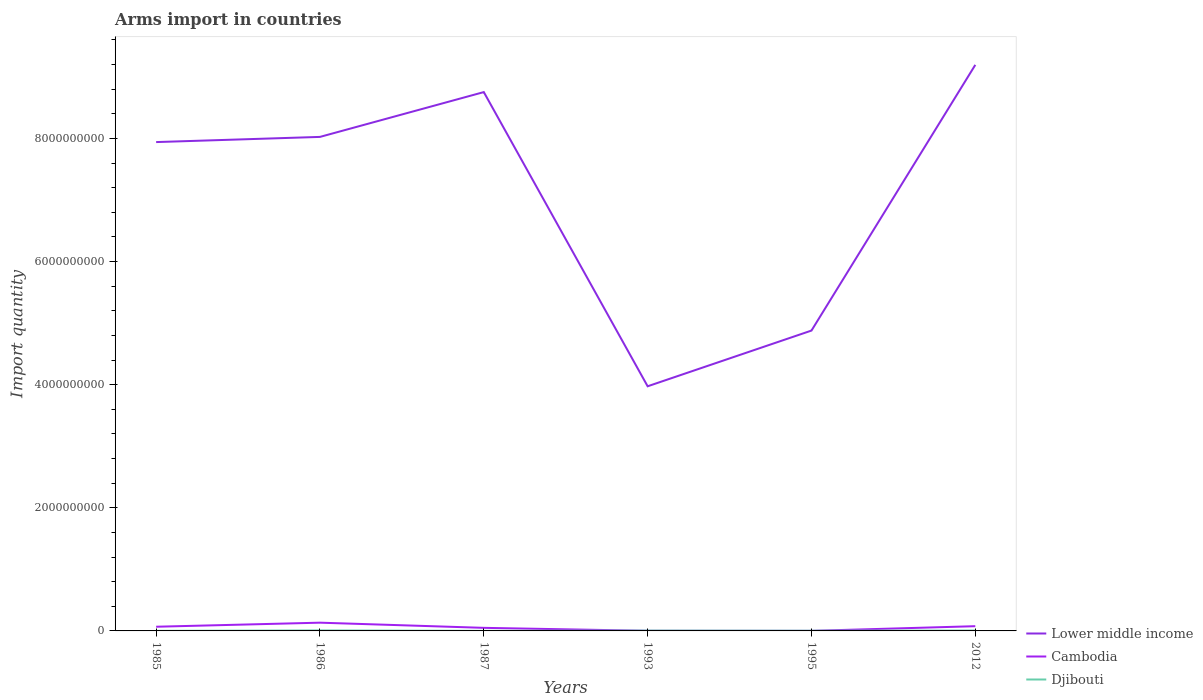How many different coloured lines are there?
Make the answer very short. 3. Is the number of lines equal to the number of legend labels?
Offer a very short reply. Yes. Across all years, what is the maximum total arms import in Djibouti?
Provide a short and direct response. 1.00e+06. In which year was the total arms import in Lower middle income maximum?
Ensure brevity in your answer.  1993. What is the difference between the highest and the second highest total arms import in Lower middle income?
Make the answer very short. 5.22e+09. Is the total arms import in Lower middle income strictly greater than the total arms import in Cambodia over the years?
Your answer should be compact. No. How many lines are there?
Provide a short and direct response. 3. What is the difference between two consecutive major ticks on the Y-axis?
Ensure brevity in your answer.  2.00e+09. Are the values on the major ticks of Y-axis written in scientific E-notation?
Your answer should be very brief. No. Does the graph contain any zero values?
Your answer should be compact. No. How many legend labels are there?
Give a very brief answer. 3. What is the title of the graph?
Make the answer very short. Arms import in countries. What is the label or title of the X-axis?
Make the answer very short. Years. What is the label or title of the Y-axis?
Make the answer very short. Import quantity. What is the Import quantity in Lower middle income in 1985?
Offer a very short reply. 7.94e+09. What is the Import quantity of Cambodia in 1985?
Offer a very short reply. 6.80e+07. What is the Import quantity of Lower middle income in 1986?
Your response must be concise. 8.02e+09. What is the Import quantity of Cambodia in 1986?
Your response must be concise. 1.34e+08. What is the Import quantity in Djibouti in 1986?
Provide a short and direct response. 8.00e+06. What is the Import quantity of Lower middle income in 1987?
Offer a very short reply. 8.75e+09. What is the Import quantity of Cambodia in 1987?
Your answer should be compact. 5.00e+07. What is the Import quantity of Lower middle income in 1993?
Provide a short and direct response. 3.97e+09. What is the Import quantity in Lower middle income in 1995?
Ensure brevity in your answer.  4.88e+09. What is the Import quantity in Cambodia in 1995?
Provide a short and direct response. 1.00e+06. What is the Import quantity of Djibouti in 1995?
Offer a very short reply. 3.00e+06. What is the Import quantity of Lower middle income in 2012?
Keep it short and to the point. 9.20e+09. What is the Import quantity of Cambodia in 2012?
Keep it short and to the point. 7.70e+07. Across all years, what is the maximum Import quantity in Lower middle income?
Make the answer very short. 9.20e+09. Across all years, what is the maximum Import quantity of Cambodia?
Your answer should be compact. 1.34e+08. Across all years, what is the maximum Import quantity of Djibouti?
Make the answer very short. 8.00e+06. Across all years, what is the minimum Import quantity of Lower middle income?
Offer a terse response. 3.97e+09. Across all years, what is the minimum Import quantity in Cambodia?
Provide a succinct answer. 1.00e+06. Across all years, what is the minimum Import quantity in Djibouti?
Offer a terse response. 1.00e+06. What is the total Import quantity in Lower middle income in the graph?
Your answer should be very brief. 4.28e+1. What is the total Import quantity in Cambodia in the graph?
Provide a short and direct response. 3.32e+08. What is the total Import quantity in Djibouti in the graph?
Ensure brevity in your answer.  2.40e+07. What is the difference between the Import quantity of Lower middle income in 1985 and that in 1986?
Make the answer very short. -8.40e+07. What is the difference between the Import quantity of Cambodia in 1985 and that in 1986?
Ensure brevity in your answer.  -6.60e+07. What is the difference between the Import quantity of Djibouti in 1985 and that in 1986?
Offer a terse response. -7.00e+06. What is the difference between the Import quantity in Lower middle income in 1985 and that in 1987?
Provide a succinct answer. -8.12e+08. What is the difference between the Import quantity in Cambodia in 1985 and that in 1987?
Provide a succinct answer. 1.80e+07. What is the difference between the Import quantity of Lower middle income in 1985 and that in 1993?
Offer a terse response. 3.97e+09. What is the difference between the Import quantity of Cambodia in 1985 and that in 1993?
Offer a very short reply. 6.60e+07. What is the difference between the Import quantity of Djibouti in 1985 and that in 1993?
Provide a short and direct response. -4.00e+06. What is the difference between the Import quantity of Lower middle income in 1985 and that in 1995?
Keep it short and to the point. 3.06e+09. What is the difference between the Import quantity in Cambodia in 1985 and that in 1995?
Your response must be concise. 6.70e+07. What is the difference between the Import quantity of Djibouti in 1985 and that in 1995?
Your response must be concise. -2.00e+06. What is the difference between the Import quantity in Lower middle income in 1985 and that in 2012?
Provide a short and direct response. -1.25e+09. What is the difference between the Import quantity in Cambodia in 1985 and that in 2012?
Provide a short and direct response. -9.00e+06. What is the difference between the Import quantity of Djibouti in 1985 and that in 2012?
Keep it short and to the point. -5.00e+06. What is the difference between the Import quantity of Lower middle income in 1986 and that in 1987?
Your answer should be compact. -7.28e+08. What is the difference between the Import quantity in Cambodia in 1986 and that in 1987?
Provide a short and direct response. 8.40e+07. What is the difference between the Import quantity in Lower middle income in 1986 and that in 1993?
Offer a very short reply. 4.05e+09. What is the difference between the Import quantity of Cambodia in 1986 and that in 1993?
Ensure brevity in your answer.  1.32e+08. What is the difference between the Import quantity of Lower middle income in 1986 and that in 1995?
Offer a very short reply. 3.15e+09. What is the difference between the Import quantity of Cambodia in 1986 and that in 1995?
Give a very brief answer. 1.33e+08. What is the difference between the Import quantity in Djibouti in 1986 and that in 1995?
Your answer should be compact. 5.00e+06. What is the difference between the Import quantity of Lower middle income in 1986 and that in 2012?
Provide a short and direct response. -1.17e+09. What is the difference between the Import quantity in Cambodia in 1986 and that in 2012?
Offer a terse response. 5.70e+07. What is the difference between the Import quantity of Lower middle income in 1987 and that in 1993?
Make the answer very short. 4.78e+09. What is the difference between the Import quantity of Cambodia in 1987 and that in 1993?
Your answer should be very brief. 4.80e+07. What is the difference between the Import quantity in Djibouti in 1987 and that in 1993?
Your response must be concise. -4.00e+06. What is the difference between the Import quantity in Lower middle income in 1987 and that in 1995?
Provide a short and direct response. 3.87e+09. What is the difference between the Import quantity of Cambodia in 1987 and that in 1995?
Your answer should be very brief. 4.90e+07. What is the difference between the Import quantity in Lower middle income in 1987 and that in 2012?
Give a very brief answer. -4.42e+08. What is the difference between the Import quantity of Cambodia in 1987 and that in 2012?
Offer a terse response. -2.70e+07. What is the difference between the Import quantity in Djibouti in 1987 and that in 2012?
Offer a terse response. -5.00e+06. What is the difference between the Import quantity of Lower middle income in 1993 and that in 1995?
Offer a terse response. -9.05e+08. What is the difference between the Import quantity of Djibouti in 1993 and that in 1995?
Offer a very short reply. 2.00e+06. What is the difference between the Import quantity in Lower middle income in 1993 and that in 2012?
Make the answer very short. -5.22e+09. What is the difference between the Import quantity of Cambodia in 1993 and that in 2012?
Ensure brevity in your answer.  -7.50e+07. What is the difference between the Import quantity in Djibouti in 1993 and that in 2012?
Give a very brief answer. -1.00e+06. What is the difference between the Import quantity of Lower middle income in 1995 and that in 2012?
Make the answer very short. -4.32e+09. What is the difference between the Import quantity of Cambodia in 1995 and that in 2012?
Provide a succinct answer. -7.60e+07. What is the difference between the Import quantity in Lower middle income in 1985 and the Import quantity in Cambodia in 1986?
Keep it short and to the point. 7.81e+09. What is the difference between the Import quantity of Lower middle income in 1985 and the Import quantity of Djibouti in 1986?
Provide a short and direct response. 7.93e+09. What is the difference between the Import quantity in Cambodia in 1985 and the Import quantity in Djibouti in 1986?
Provide a short and direct response. 6.00e+07. What is the difference between the Import quantity in Lower middle income in 1985 and the Import quantity in Cambodia in 1987?
Make the answer very short. 7.89e+09. What is the difference between the Import quantity in Lower middle income in 1985 and the Import quantity in Djibouti in 1987?
Provide a short and direct response. 7.94e+09. What is the difference between the Import quantity of Cambodia in 1985 and the Import quantity of Djibouti in 1987?
Your response must be concise. 6.70e+07. What is the difference between the Import quantity in Lower middle income in 1985 and the Import quantity in Cambodia in 1993?
Offer a very short reply. 7.94e+09. What is the difference between the Import quantity of Lower middle income in 1985 and the Import quantity of Djibouti in 1993?
Offer a terse response. 7.94e+09. What is the difference between the Import quantity of Cambodia in 1985 and the Import quantity of Djibouti in 1993?
Provide a succinct answer. 6.30e+07. What is the difference between the Import quantity in Lower middle income in 1985 and the Import quantity in Cambodia in 1995?
Offer a terse response. 7.94e+09. What is the difference between the Import quantity of Lower middle income in 1985 and the Import quantity of Djibouti in 1995?
Your answer should be compact. 7.94e+09. What is the difference between the Import quantity of Cambodia in 1985 and the Import quantity of Djibouti in 1995?
Give a very brief answer. 6.50e+07. What is the difference between the Import quantity of Lower middle income in 1985 and the Import quantity of Cambodia in 2012?
Your answer should be very brief. 7.86e+09. What is the difference between the Import quantity of Lower middle income in 1985 and the Import quantity of Djibouti in 2012?
Provide a short and direct response. 7.94e+09. What is the difference between the Import quantity in Cambodia in 1985 and the Import quantity in Djibouti in 2012?
Your answer should be compact. 6.20e+07. What is the difference between the Import quantity in Lower middle income in 1986 and the Import quantity in Cambodia in 1987?
Your answer should be compact. 7.98e+09. What is the difference between the Import quantity of Lower middle income in 1986 and the Import quantity of Djibouti in 1987?
Ensure brevity in your answer.  8.02e+09. What is the difference between the Import quantity in Cambodia in 1986 and the Import quantity in Djibouti in 1987?
Ensure brevity in your answer.  1.33e+08. What is the difference between the Import quantity of Lower middle income in 1986 and the Import quantity of Cambodia in 1993?
Offer a terse response. 8.02e+09. What is the difference between the Import quantity in Lower middle income in 1986 and the Import quantity in Djibouti in 1993?
Ensure brevity in your answer.  8.02e+09. What is the difference between the Import quantity in Cambodia in 1986 and the Import quantity in Djibouti in 1993?
Offer a very short reply. 1.29e+08. What is the difference between the Import quantity in Lower middle income in 1986 and the Import quantity in Cambodia in 1995?
Give a very brief answer. 8.02e+09. What is the difference between the Import quantity of Lower middle income in 1986 and the Import quantity of Djibouti in 1995?
Ensure brevity in your answer.  8.02e+09. What is the difference between the Import quantity in Cambodia in 1986 and the Import quantity in Djibouti in 1995?
Give a very brief answer. 1.31e+08. What is the difference between the Import quantity of Lower middle income in 1986 and the Import quantity of Cambodia in 2012?
Offer a very short reply. 7.95e+09. What is the difference between the Import quantity of Lower middle income in 1986 and the Import quantity of Djibouti in 2012?
Your answer should be very brief. 8.02e+09. What is the difference between the Import quantity of Cambodia in 1986 and the Import quantity of Djibouti in 2012?
Your answer should be very brief. 1.28e+08. What is the difference between the Import quantity in Lower middle income in 1987 and the Import quantity in Cambodia in 1993?
Give a very brief answer. 8.75e+09. What is the difference between the Import quantity in Lower middle income in 1987 and the Import quantity in Djibouti in 1993?
Offer a terse response. 8.75e+09. What is the difference between the Import quantity of Cambodia in 1987 and the Import quantity of Djibouti in 1993?
Ensure brevity in your answer.  4.50e+07. What is the difference between the Import quantity of Lower middle income in 1987 and the Import quantity of Cambodia in 1995?
Give a very brief answer. 8.75e+09. What is the difference between the Import quantity of Lower middle income in 1987 and the Import quantity of Djibouti in 1995?
Provide a succinct answer. 8.75e+09. What is the difference between the Import quantity of Cambodia in 1987 and the Import quantity of Djibouti in 1995?
Keep it short and to the point. 4.70e+07. What is the difference between the Import quantity of Lower middle income in 1987 and the Import quantity of Cambodia in 2012?
Offer a terse response. 8.68e+09. What is the difference between the Import quantity in Lower middle income in 1987 and the Import quantity in Djibouti in 2012?
Keep it short and to the point. 8.75e+09. What is the difference between the Import quantity of Cambodia in 1987 and the Import quantity of Djibouti in 2012?
Make the answer very short. 4.40e+07. What is the difference between the Import quantity of Lower middle income in 1993 and the Import quantity of Cambodia in 1995?
Offer a very short reply. 3.97e+09. What is the difference between the Import quantity of Lower middle income in 1993 and the Import quantity of Djibouti in 1995?
Offer a terse response. 3.97e+09. What is the difference between the Import quantity of Cambodia in 1993 and the Import quantity of Djibouti in 1995?
Your response must be concise. -1.00e+06. What is the difference between the Import quantity of Lower middle income in 1993 and the Import quantity of Cambodia in 2012?
Give a very brief answer. 3.90e+09. What is the difference between the Import quantity in Lower middle income in 1993 and the Import quantity in Djibouti in 2012?
Give a very brief answer. 3.97e+09. What is the difference between the Import quantity in Lower middle income in 1995 and the Import quantity in Cambodia in 2012?
Keep it short and to the point. 4.80e+09. What is the difference between the Import quantity in Lower middle income in 1995 and the Import quantity in Djibouti in 2012?
Your answer should be very brief. 4.87e+09. What is the difference between the Import quantity in Cambodia in 1995 and the Import quantity in Djibouti in 2012?
Make the answer very short. -5.00e+06. What is the average Import quantity in Lower middle income per year?
Keep it short and to the point. 7.13e+09. What is the average Import quantity in Cambodia per year?
Provide a short and direct response. 5.53e+07. What is the average Import quantity of Djibouti per year?
Provide a succinct answer. 4.00e+06. In the year 1985, what is the difference between the Import quantity in Lower middle income and Import quantity in Cambodia?
Make the answer very short. 7.87e+09. In the year 1985, what is the difference between the Import quantity of Lower middle income and Import quantity of Djibouti?
Provide a succinct answer. 7.94e+09. In the year 1985, what is the difference between the Import quantity of Cambodia and Import quantity of Djibouti?
Offer a very short reply. 6.70e+07. In the year 1986, what is the difference between the Import quantity of Lower middle income and Import quantity of Cambodia?
Your answer should be compact. 7.89e+09. In the year 1986, what is the difference between the Import quantity in Lower middle income and Import quantity in Djibouti?
Your answer should be very brief. 8.02e+09. In the year 1986, what is the difference between the Import quantity of Cambodia and Import quantity of Djibouti?
Offer a terse response. 1.26e+08. In the year 1987, what is the difference between the Import quantity of Lower middle income and Import quantity of Cambodia?
Your response must be concise. 8.70e+09. In the year 1987, what is the difference between the Import quantity of Lower middle income and Import quantity of Djibouti?
Your response must be concise. 8.75e+09. In the year 1987, what is the difference between the Import quantity of Cambodia and Import quantity of Djibouti?
Keep it short and to the point. 4.90e+07. In the year 1993, what is the difference between the Import quantity in Lower middle income and Import quantity in Cambodia?
Your answer should be compact. 3.97e+09. In the year 1993, what is the difference between the Import quantity in Lower middle income and Import quantity in Djibouti?
Provide a succinct answer. 3.97e+09. In the year 1993, what is the difference between the Import quantity of Cambodia and Import quantity of Djibouti?
Give a very brief answer. -3.00e+06. In the year 1995, what is the difference between the Import quantity of Lower middle income and Import quantity of Cambodia?
Offer a very short reply. 4.88e+09. In the year 1995, what is the difference between the Import quantity in Lower middle income and Import quantity in Djibouti?
Provide a short and direct response. 4.88e+09. In the year 2012, what is the difference between the Import quantity in Lower middle income and Import quantity in Cambodia?
Provide a short and direct response. 9.12e+09. In the year 2012, what is the difference between the Import quantity in Lower middle income and Import quantity in Djibouti?
Offer a very short reply. 9.19e+09. In the year 2012, what is the difference between the Import quantity in Cambodia and Import quantity in Djibouti?
Keep it short and to the point. 7.10e+07. What is the ratio of the Import quantity of Lower middle income in 1985 to that in 1986?
Offer a terse response. 0.99. What is the ratio of the Import quantity of Cambodia in 1985 to that in 1986?
Give a very brief answer. 0.51. What is the ratio of the Import quantity of Lower middle income in 1985 to that in 1987?
Give a very brief answer. 0.91. What is the ratio of the Import quantity in Cambodia in 1985 to that in 1987?
Provide a succinct answer. 1.36. What is the ratio of the Import quantity in Lower middle income in 1985 to that in 1993?
Offer a terse response. 2. What is the ratio of the Import quantity in Cambodia in 1985 to that in 1993?
Make the answer very short. 34. What is the ratio of the Import quantity of Djibouti in 1985 to that in 1993?
Provide a succinct answer. 0.2. What is the ratio of the Import quantity in Lower middle income in 1985 to that in 1995?
Provide a succinct answer. 1.63. What is the ratio of the Import quantity in Cambodia in 1985 to that in 1995?
Give a very brief answer. 68. What is the ratio of the Import quantity in Djibouti in 1985 to that in 1995?
Provide a succinct answer. 0.33. What is the ratio of the Import quantity of Lower middle income in 1985 to that in 2012?
Offer a very short reply. 0.86. What is the ratio of the Import quantity of Cambodia in 1985 to that in 2012?
Provide a short and direct response. 0.88. What is the ratio of the Import quantity of Lower middle income in 1986 to that in 1987?
Provide a succinct answer. 0.92. What is the ratio of the Import quantity in Cambodia in 1986 to that in 1987?
Give a very brief answer. 2.68. What is the ratio of the Import quantity in Djibouti in 1986 to that in 1987?
Your answer should be very brief. 8. What is the ratio of the Import quantity in Lower middle income in 1986 to that in 1993?
Give a very brief answer. 2.02. What is the ratio of the Import quantity of Lower middle income in 1986 to that in 1995?
Your answer should be compact. 1.64. What is the ratio of the Import quantity in Cambodia in 1986 to that in 1995?
Your response must be concise. 134. What is the ratio of the Import quantity in Djibouti in 1986 to that in 1995?
Your answer should be compact. 2.67. What is the ratio of the Import quantity in Lower middle income in 1986 to that in 2012?
Provide a short and direct response. 0.87. What is the ratio of the Import quantity of Cambodia in 1986 to that in 2012?
Offer a terse response. 1.74. What is the ratio of the Import quantity in Lower middle income in 1987 to that in 1993?
Provide a short and direct response. 2.2. What is the ratio of the Import quantity of Djibouti in 1987 to that in 1993?
Provide a short and direct response. 0.2. What is the ratio of the Import quantity in Lower middle income in 1987 to that in 1995?
Give a very brief answer. 1.79. What is the ratio of the Import quantity of Djibouti in 1987 to that in 1995?
Make the answer very short. 0.33. What is the ratio of the Import quantity of Lower middle income in 1987 to that in 2012?
Keep it short and to the point. 0.95. What is the ratio of the Import quantity of Cambodia in 1987 to that in 2012?
Provide a short and direct response. 0.65. What is the ratio of the Import quantity in Lower middle income in 1993 to that in 1995?
Provide a short and direct response. 0.81. What is the ratio of the Import quantity of Cambodia in 1993 to that in 1995?
Your answer should be compact. 2. What is the ratio of the Import quantity in Djibouti in 1993 to that in 1995?
Offer a terse response. 1.67. What is the ratio of the Import quantity in Lower middle income in 1993 to that in 2012?
Ensure brevity in your answer.  0.43. What is the ratio of the Import quantity of Cambodia in 1993 to that in 2012?
Your answer should be compact. 0.03. What is the ratio of the Import quantity in Lower middle income in 1995 to that in 2012?
Offer a terse response. 0.53. What is the ratio of the Import quantity of Cambodia in 1995 to that in 2012?
Give a very brief answer. 0.01. What is the ratio of the Import quantity of Djibouti in 1995 to that in 2012?
Your answer should be very brief. 0.5. What is the difference between the highest and the second highest Import quantity in Lower middle income?
Provide a short and direct response. 4.42e+08. What is the difference between the highest and the second highest Import quantity of Cambodia?
Make the answer very short. 5.70e+07. What is the difference between the highest and the lowest Import quantity in Lower middle income?
Ensure brevity in your answer.  5.22e+09. What is the difference between the highest and the lowest Import quantity of Cambodia?
Your response must be concise. 1.33e+08. What is the difference between the highest and the lowest Import quantity in Djibouti?
Offer a very short reply. 7.00e+06. 